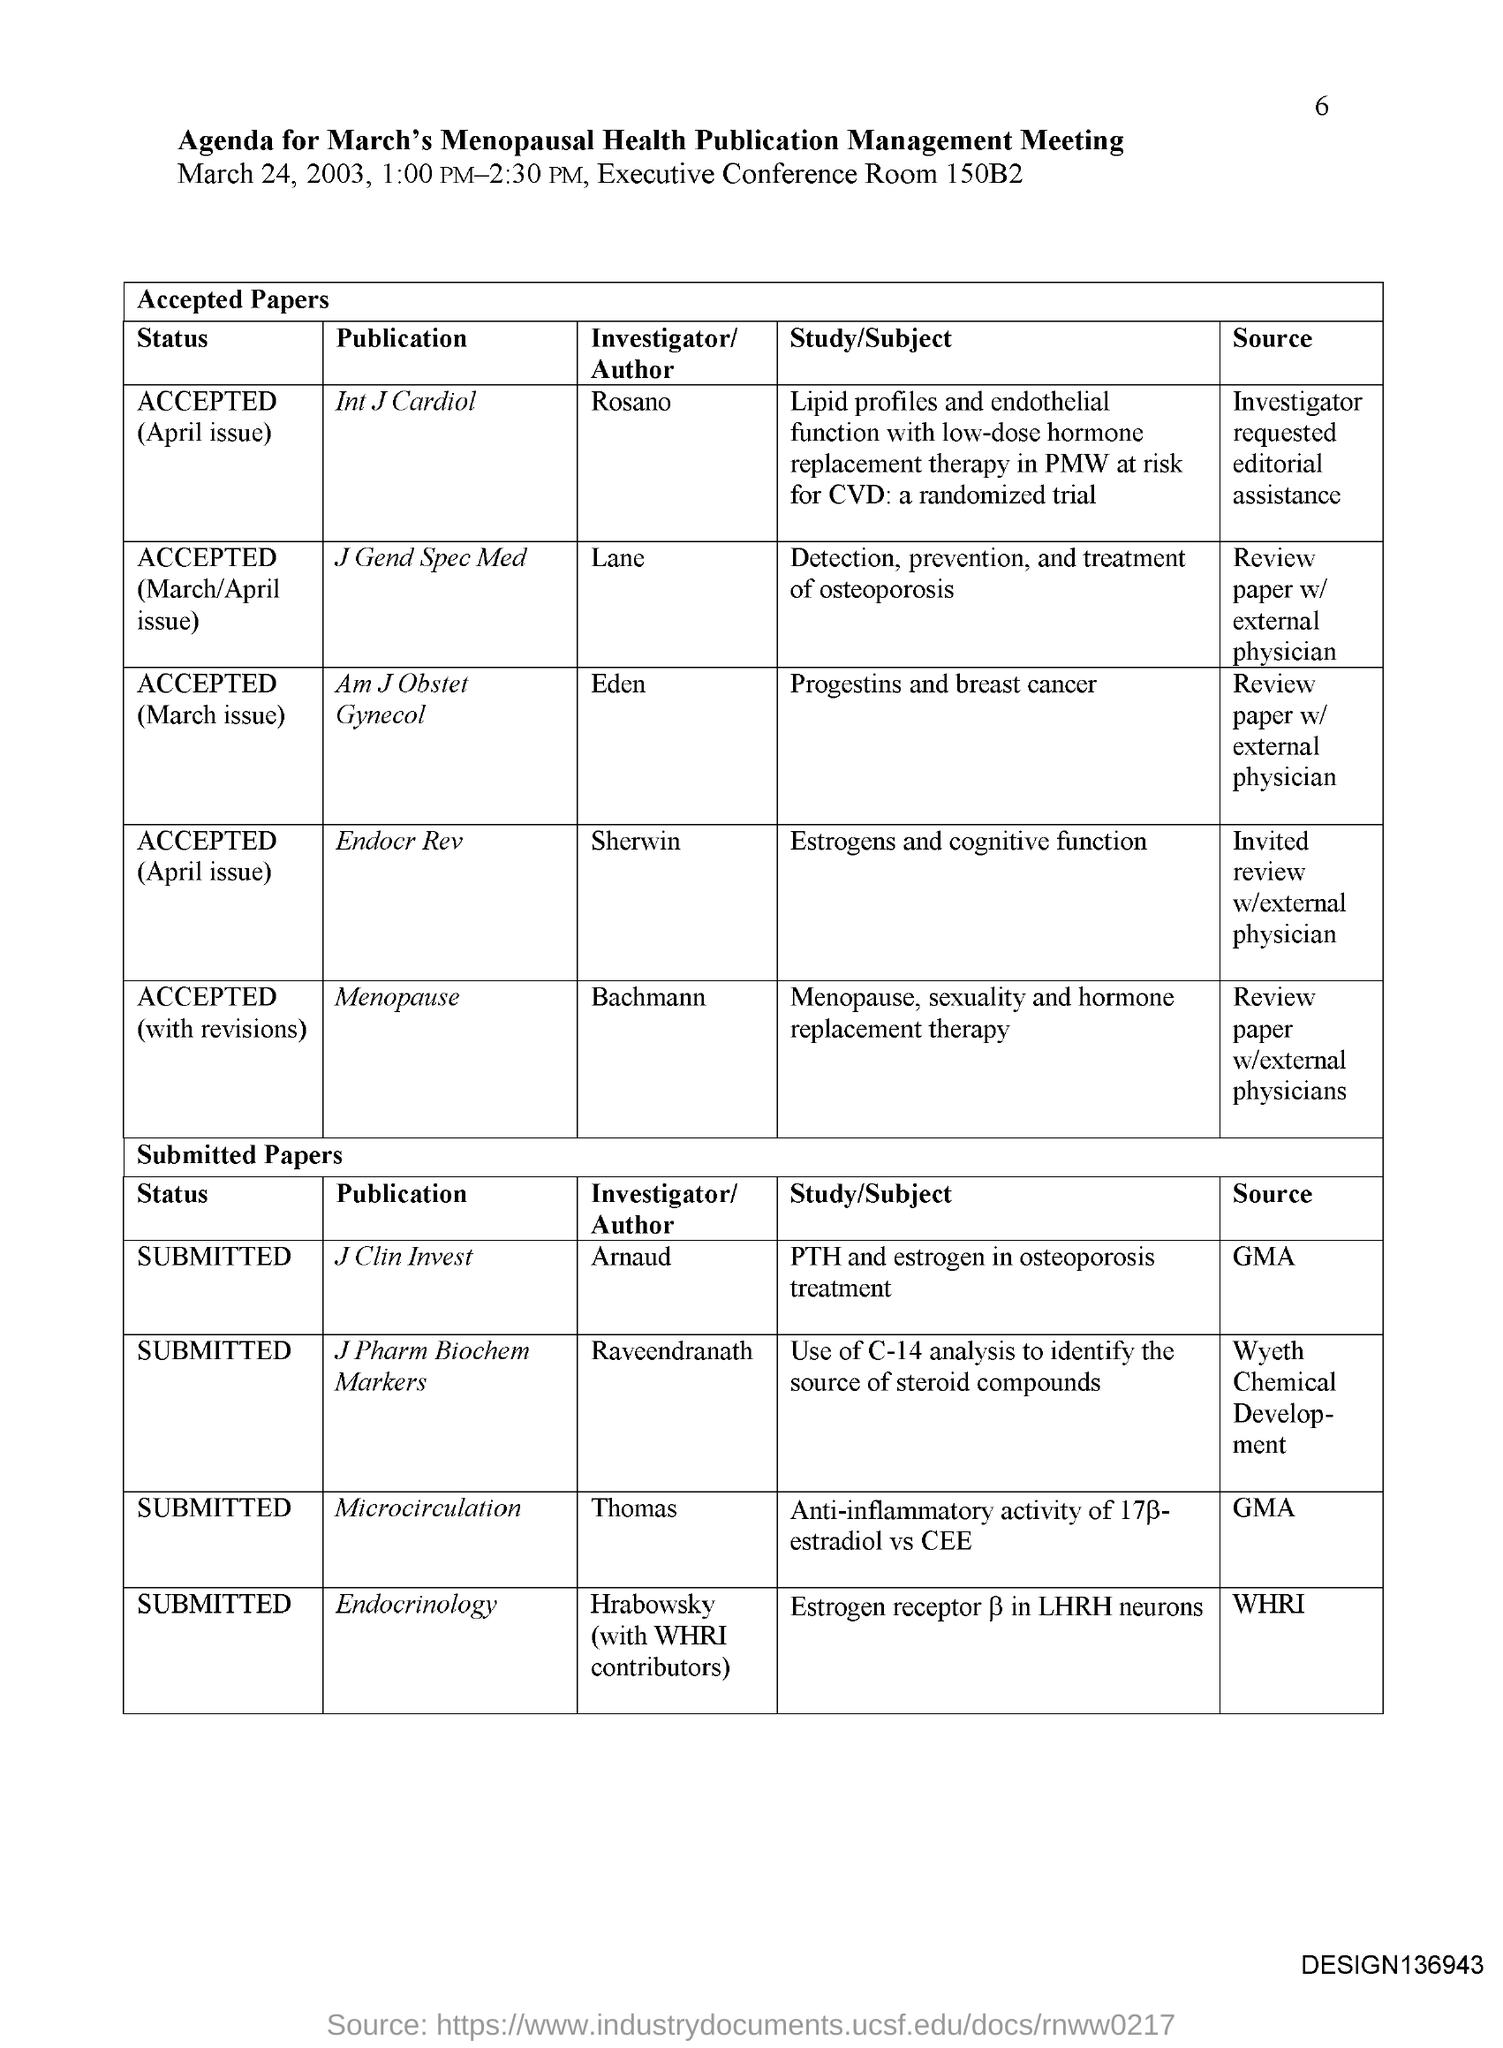Draw attention to some important aspects in this diagram. The publication "Endocrinology" is currently in the status of submission. The author of the publication "J Gend Spec Med" is Lane. Arnaud is the author of the publication titled 'J Clin Invest.' The status of the publication "J Clin Invest" is currently submitted. The publication "Menopause" is authored by Bachmann. 